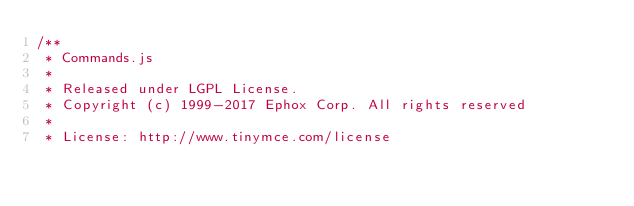<code> <loc_0><loc_0><loc_500><loc_500><_JavaScript_>/**
 * Commands.js
 *
 * Released under LGPL License.
 * Copyright (c) 1999-2017 Ephox Corp. All rights reserved
 *
 * License: http://www.tinymce.com/license</code> 